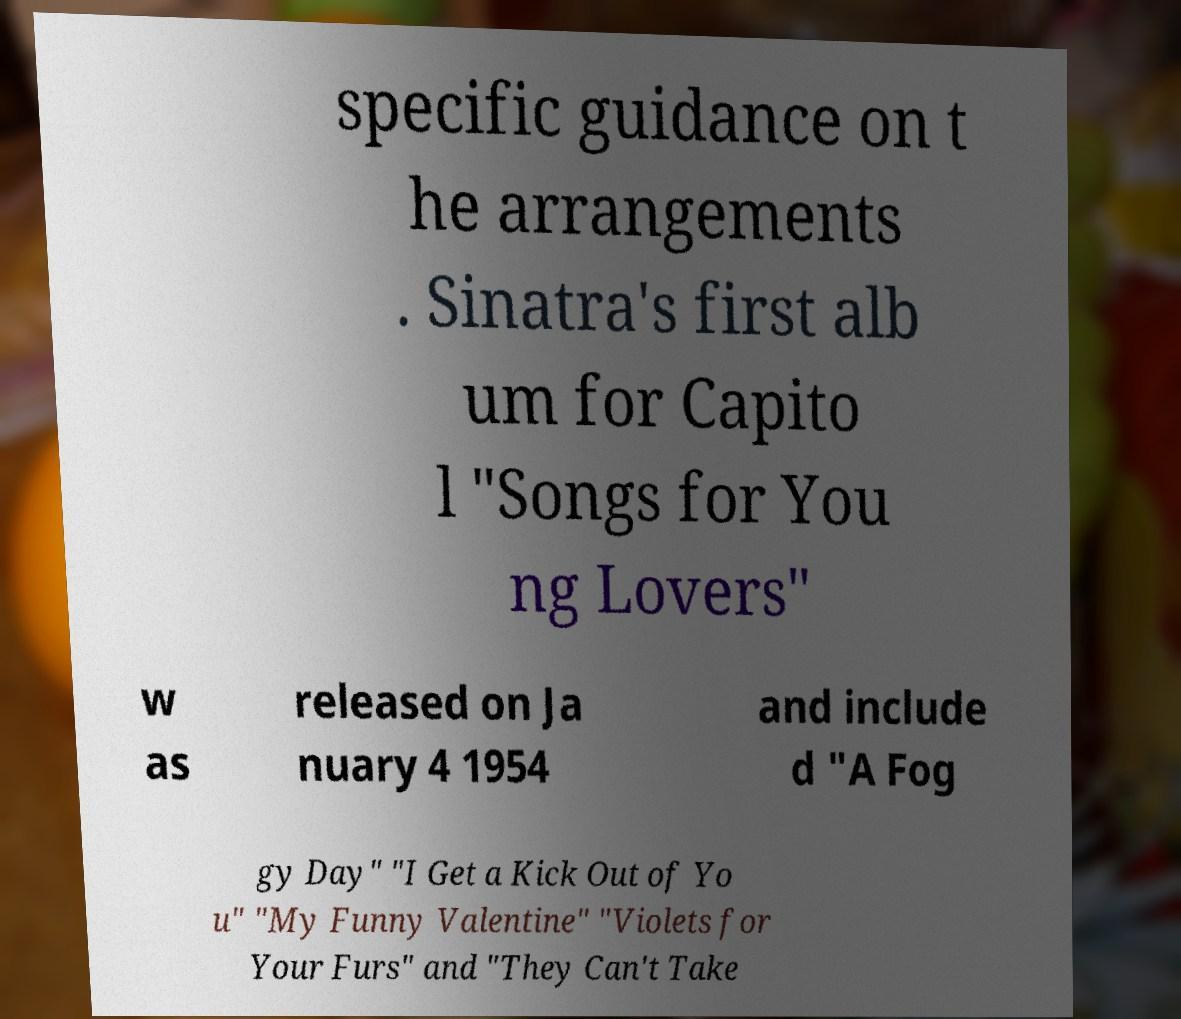What messages or text are displayed in this image? I need them in a readable, typed format. specific guidance on t he arrangements . Sinatra's first alb um for Capito l "Songs for You ng Lovers" w as released on Ja nuary 4 1954 and include d "A Fog gy Day" "I Get a Kick Out of Yo u" "My Funny Valentine" "Violets for Your Furs" and "They Can't Take 